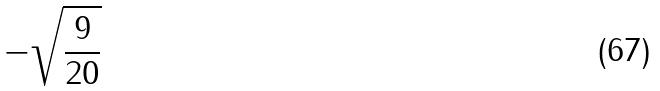<formula> <loc_0><loc_0><loc_500><loc_500>- \sqrt { \frac { 9 } { 2 0 } }</formula> 